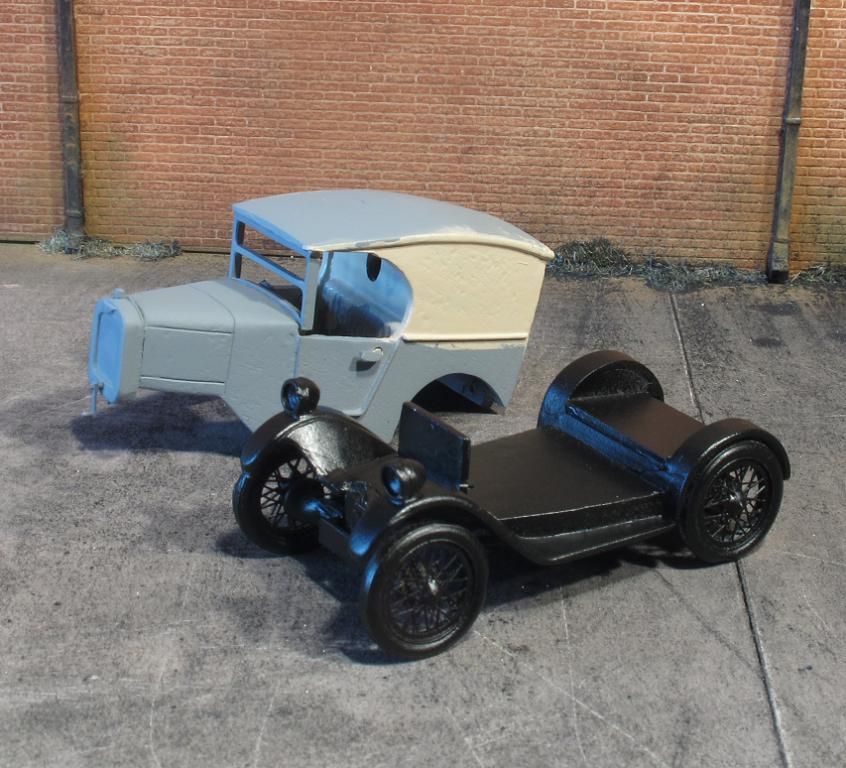What type of objects are present in the image? There are parts of vehicles in the image. What can be seen in the background of the image? There is a wall of bricks in the background of the image. What verse is being recited by the vehicle parts in the image? There are no vehicle parts capable of reciting verses in the image. How much sugar is present in the image? There is no sugar visible in the image. 